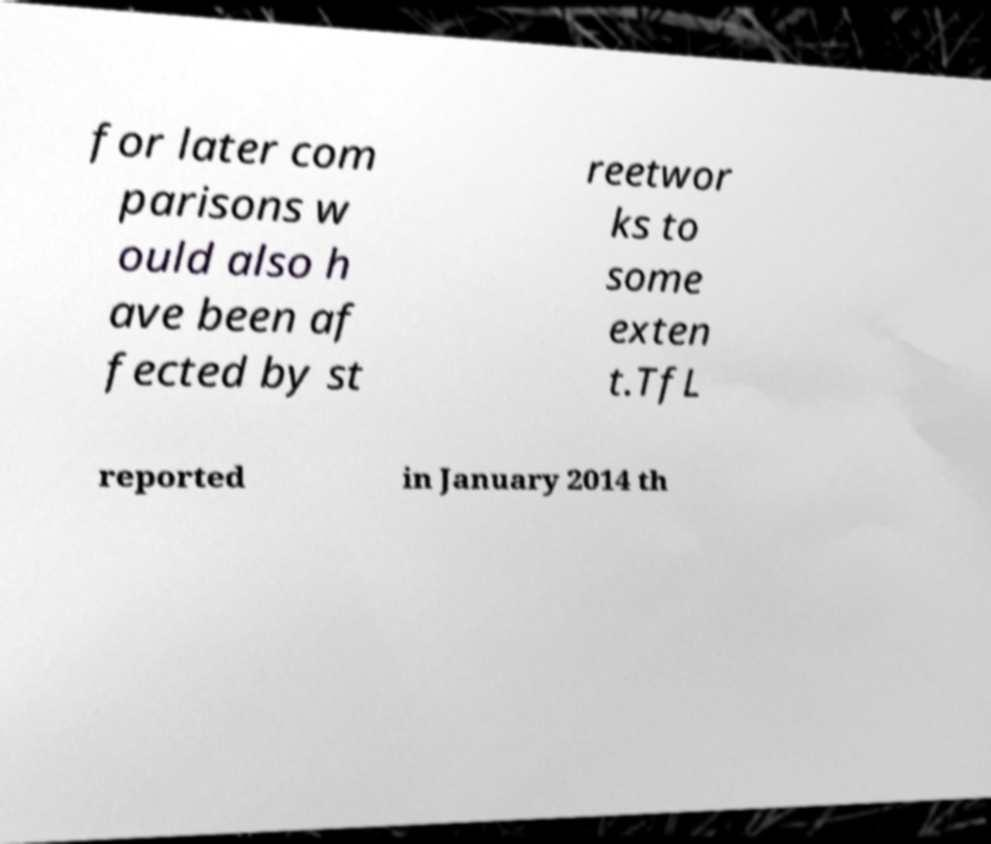Can you accurately transcribe the text from the provided image for me? for later com parisons w ould also h ave been af fected by st reetwor ks to some exten t.TfL reported in January 2014 th 